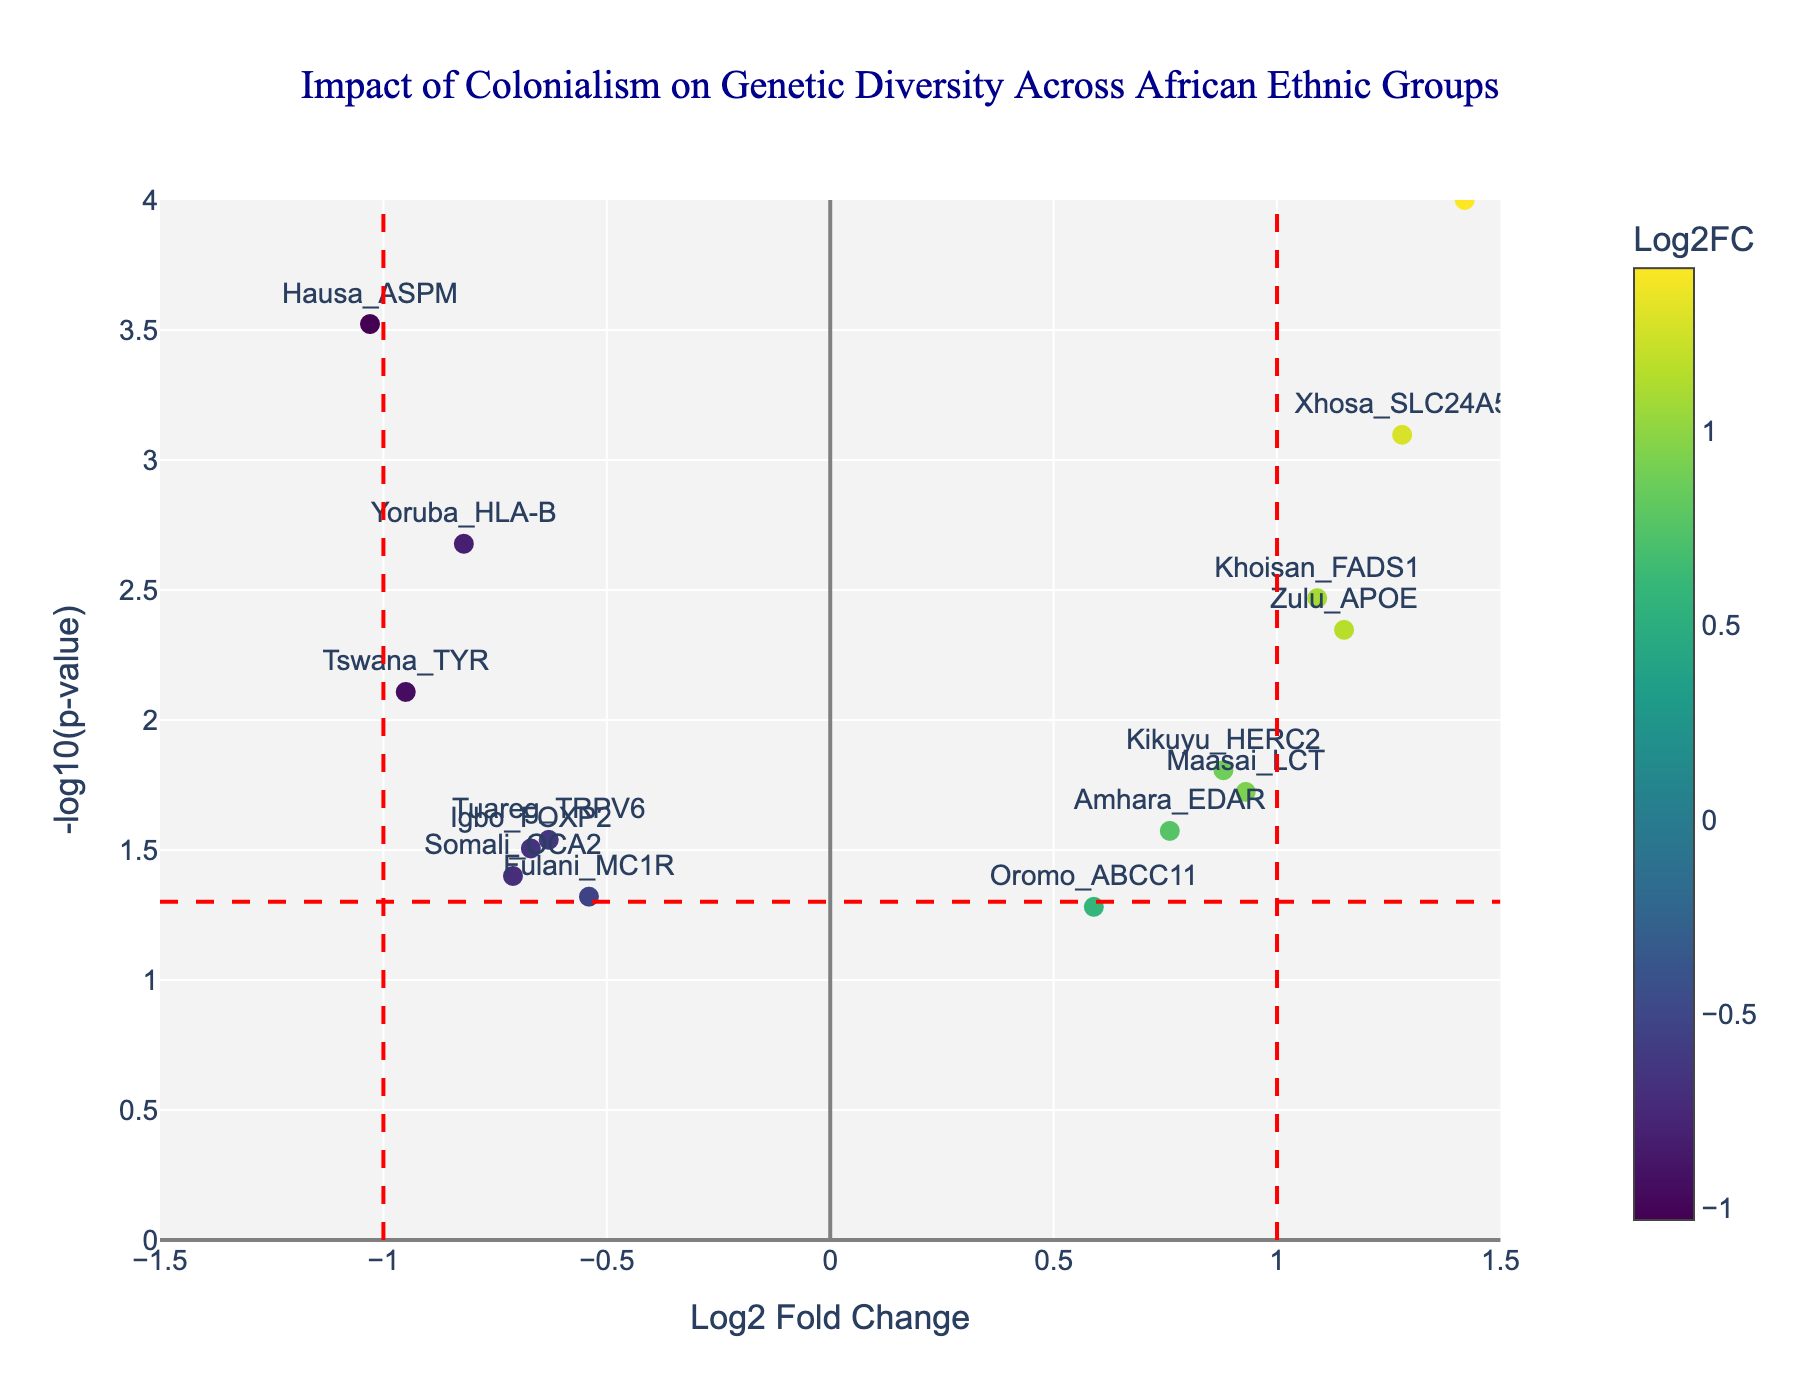Which ethnic group has the highest -log10(p-value)? To find the ethnic group with the highest -log10(p-value), locate the point at the topmost part of the plot. The Mandinka_SLC45A2 data point is the furthest point on the y-axis
Answer: Mandinka_SLC45A2 What does the vertical red dashed line at Log2FC = 1 signify? The vertical red dashed lines usually delineate fold change thresholds. Here, Log2FC = 1 indicates a positive regulatory threshold related to gene expression changes.
Answer: Fold change threshold What gene is associated with the lowest Log2FC value? To find the gene with the lowest Log2FC value, look for the leftmost data point on the x-axis. The gene at Log2FC = -1.03 is Hausa_ASPM
Answer: Hausa_ASPM How many genes have a -log10(p-value) greater than 2? Identify all data points above the y-axis value of 2. By counting, Hausa_ASPM, Mandinka_SLC45A2, and Xhosa_SLC24A5 meet this criterion
Answer: Three genes Which gene is closest to the Log2FC of 0 while having a significant p-value? Examine the data points near Log2FC = 0 and identify the gene with the higher -log10(p-value). Oromo_ABCC11 is closest to Log2FC=0 with a somewhat significant p-value
Answer: Oromo_ABCC11 What is the relationship between the color of the data points and the Log2FC values? In the plot, the color scale (Viridis) represents Log2FC values. Low Log2FC points are in darker colors, and high values are in lighter colors.
Answer: Color indicates Log2FC Compare the -log10(p-value) of Xhosa_SLC24A5 and Yoruba_HLA-B. Which one is higher? Locate the respective data points on the y-axis. Xhosa_SLC24A5 has a higher -log10(p-value) compared to Yoruba_HLA-B
Answer: Xhosa_SLC24A5 Which gene shows a high Log2FC but doesn’t pass the significance threshold (p-value < 0.05)? Look at the data points with Log2FC > 0 and -log10(p-value) just below the significance threshold line. Oromo_ABCC11 fits this criterion
Answer: Oromo_ABCC11 